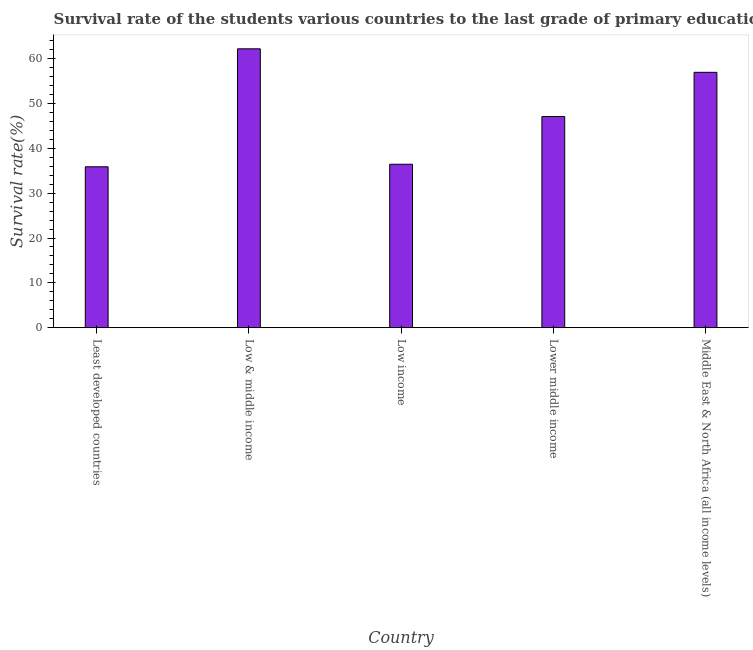Does the graph contain any zero values?
Ensure brevity in your answer.  No. Does the graph contain grids?
Offer a terse response. No. What is the title of the graph?
Offer a terse response. Survival rate of the students various countries to the last grade of primary education. What is the label or title of the Y-axis?
Give a very brief answer. Survival rate(%). What is the survival rate in primary education in Low income?
Keep it short and to the point. 36.45. Across all countries, what is the maximum survival rate in primary education?
Keep it short and to the point. 62.2. Across all countries, what is the minimum survival rate in primary education?
Provide a succinct answer. 35.89. In which country was the survival rate in primary education maximum?
Offer a very short reply. Low & middle income. In which country was the survival rate in primary education minimum?
Your answer should be compact. Least developed countries. What is the sum of the survival rate in primary education?
Your response must be concise. 238.6. What is the difference between the survival rate in primary education in Low & middle income and Low income?
Provide a succinct answer. 25.75. What is the average survival rate in primary education per country?
Offer a very short reply. 47.72. What is the median survival rate in primary education?
Your answer should be very brief. 47.09. In how many countries, is the survival rate in primary education greater than 12 %?
Provide a succinct answer. 5. What is the ratio of the survival rate in primary education in Lower middle income to that in Middle East & North Africa (all income levels)?
Offer a very short reply. 0.83. Is the difference between the survival rate in primary education in Least developed countries and Lower middle income greater than the difference between any two countries?
Offer a terse response. No. What is the difference between the highest and the second highest survival rate in primary education?
Your response must be concise. 5.24. Is the sum of the survival rate in primary education in Lower middle income and Middle East & North Africa (all income levels) greater than the maximum survival rate in primary education across all countries?
Your answer should be compact. Yes. What is the difference between the highest and the lowest survival rate in primary education?
Keep it short and to the point. 26.32. Are all the bars in the graph horizontal?
Give a very brief answer. No. What is the Survival rate(%) of Least developed countries?
Offer a very short reply. 35.89. What is the Survival rate(%) of Low & middle income?
Your answer should be compact. 62.2. What is the Survival rate(%) of Low income?
Your answer should be compact. 36.45. What is the Survival rate(%) in Lower middle income?
Give a very brief answer. 47.09. What is the Survival rate(%) in Middle East & North Africa (all income levels)?
Keep it short and to the point. 56.96. What is the difference between the Survival rate(%) in Least developed countries and Low & middle income?
Offer a terse response. -26.32. What is the difference between the Survival rate(%) in Least developed countries and Low income?
Ensure brevity in your answer.  -0.56. What is the difference between the Survival rate(%) in Least developed countries and Lower middle income?
Your response must be concise. -11.21. What is the difference between the Survival rate(%) in Least developed countries and Middle East & North Africa (all income levels)?
Your answer should be very brief. -21.07. What is the difference between the Survival rate(%) in Low & middle income and Low income?
Offer a terse response. 25.75. What is the difference between the Survival rate(%) in Low & middle income and Lower middle income?
Provide a short and direct response. 15.11. What is the difference between the Survival rate(%) in Low & middle income and Middle East & North Africa (all income levels)?
Keep it short and to the point. 5.24. What is the difference between the Survival rate(%) in Low income and Lower middle income?
Offer a terse response. -10.64. What is the difference between the Survival rate(%) in Low income and Middle East & North Africa (all income levels)?
Keep it short and to the point. -20.51. What is the difference between the Survival rate(%) in Lower middle income and Middle East & North Africa (all income levels)?
Provide a short and direct response. -9.87. What is the ratio of the Survival rate(%) in Least developed countries to that in Low & middle income?
Provide a short and direct response. 0.58. What is the ratio of the Survival rate(%) in Least developed countries to that in Low income?
Provide a succinct answer. 0.98. What is the ratio of the Survival rate(%) in Least developed countries to that in Lower middle income?
Your answer should be compact. 0.76. What is the ratio of the Survival rate(%) in Least developed countries to that in Middle East & North Africa (all income levels)?
Offer a terse response. 0.63. What is the ratio of the Survival rate(%) in Low & middle income to that in Low income?
Offer a very short reply. 1.71. What is the ratio of the Survival rate(%) in Low & middle income to that in Lower middle income?
Make the answer very short. 1.32. What is the ratio of the Survival rate(%) in Low & middle income to that in Middle East & North Africa (all income levels)?
Offer a very short reply. 1.09. What is the ratio of the Survival rate(%) in Low income to that in Lower middle income?
Give a very brief answer. 0.77. What is the ratio of the Survival rate(%) in Low income to that in Middle East & North Africa (all income levels)?
Your answer should be compact. 0.64. What is the ratio of the Survival rate(%) in Lower middle income to that in Middle East & North Africa (all income levels)?
Keep it short and to the point. 0.83. 